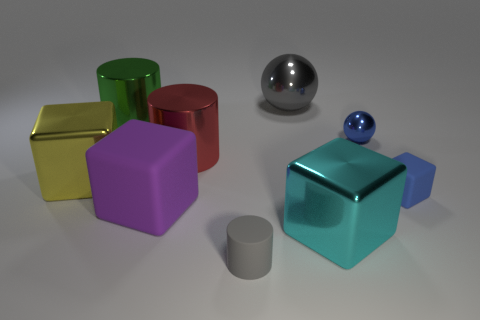There is a rubber thing that is in front of the cyan shiny block; is its size the same as the tiny metal ball?
Your answer should be compact. Yes. How many other rubber blocks have the same color as the tiny cube?
Keep it short and to the point. 0. Does the green shiny object have the same shape as the large rubber object?
Keep it short and to the point. No. Is there anything else that has the same size as the blue matte object?
Provide a succinct answer. Yes. What is the size of the blue object that is the same shape as the large yellow thing?
Your answer should be compact. Small. Are there more blue spheres that are on the left side of the purple cube than tiny gray rubber objects that are on the right side of the small cylinder?
Offer a terse response. No. Is the green cylinder made of the same material as the gray thing that is behind the small shiny ball?
Give a very brief answer. Yes. Is there anything else that has the same shape as the big green metallic thing?
Provide a short and direct response. Yes. There is a large object that is both in front of the red metal thing and left of the purple matte thing; what color is it?
Make the answer very short. Yellow. What is the shape of the thing that is to the left of the large green metal object?
Ensure brevity in your answer.  Cube. 